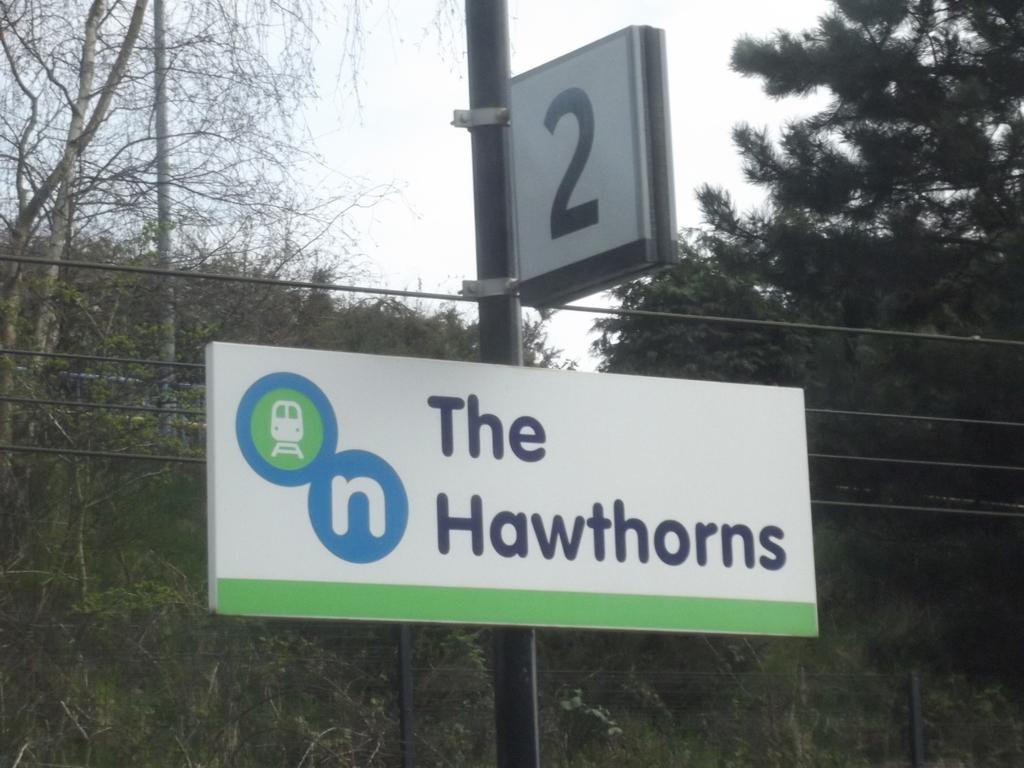<image>
Relay a brief, clear account of the picture shown. A sign that says The Hawthorns on it. 